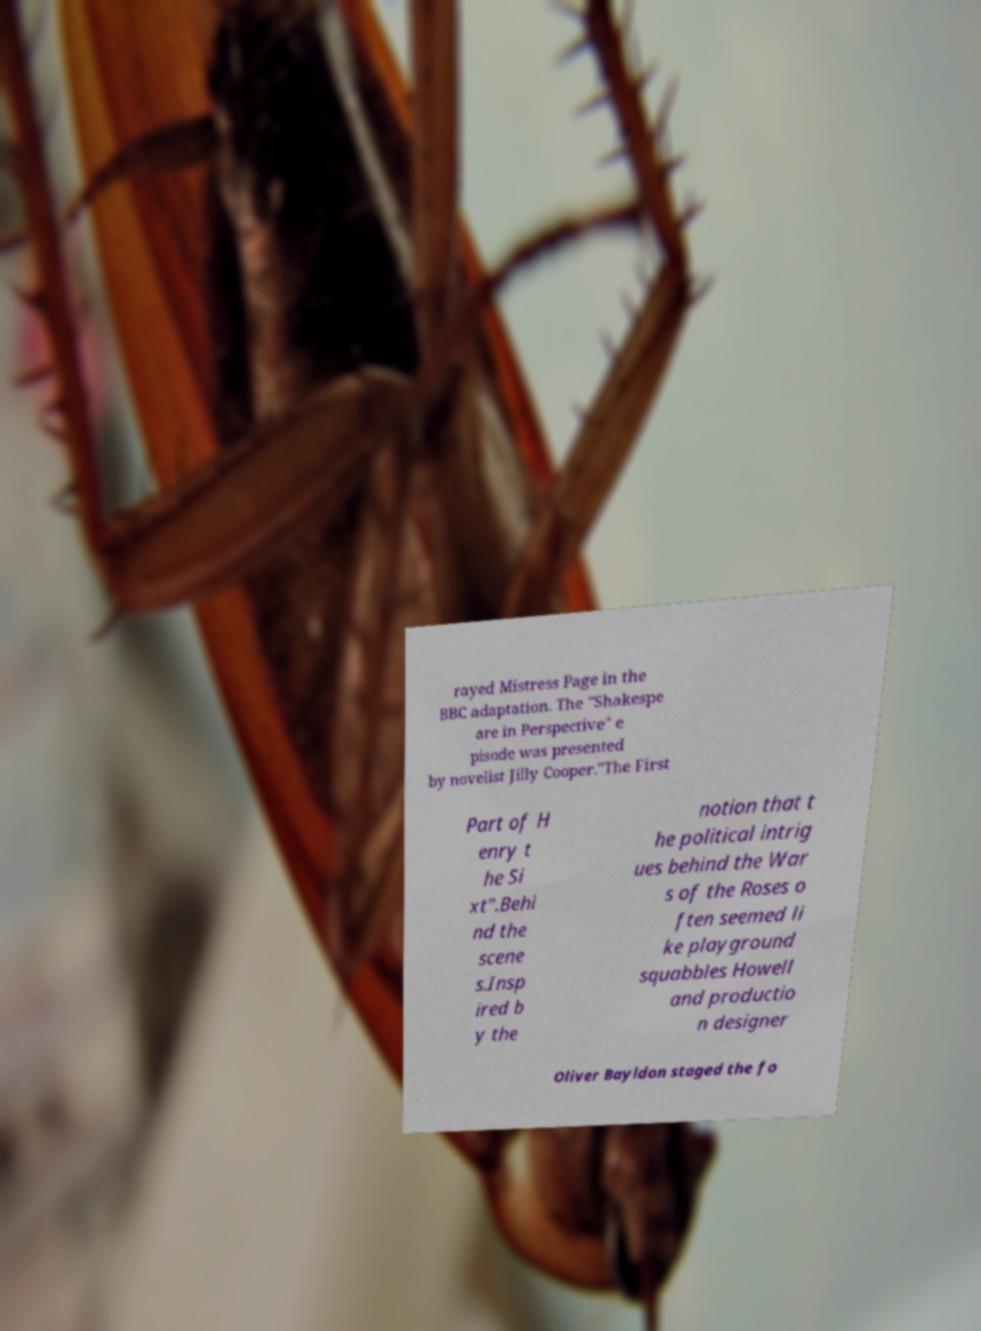I need the written content from this picture converted into text. Can you do that? rayed Mistress Page in the BBC adaptation. The "Shakespe are in Perspective" e pisode was presented by novelist Jilly Cooper."The First Part of H enry t he Si xt".Behi nd the scene s.Insp ired b y the notion that t he political intrig ues behind the War s of the Roses o ften seemed li ke playground squabbles Howell and productio n designer Oliver Bayldon staged the fo 